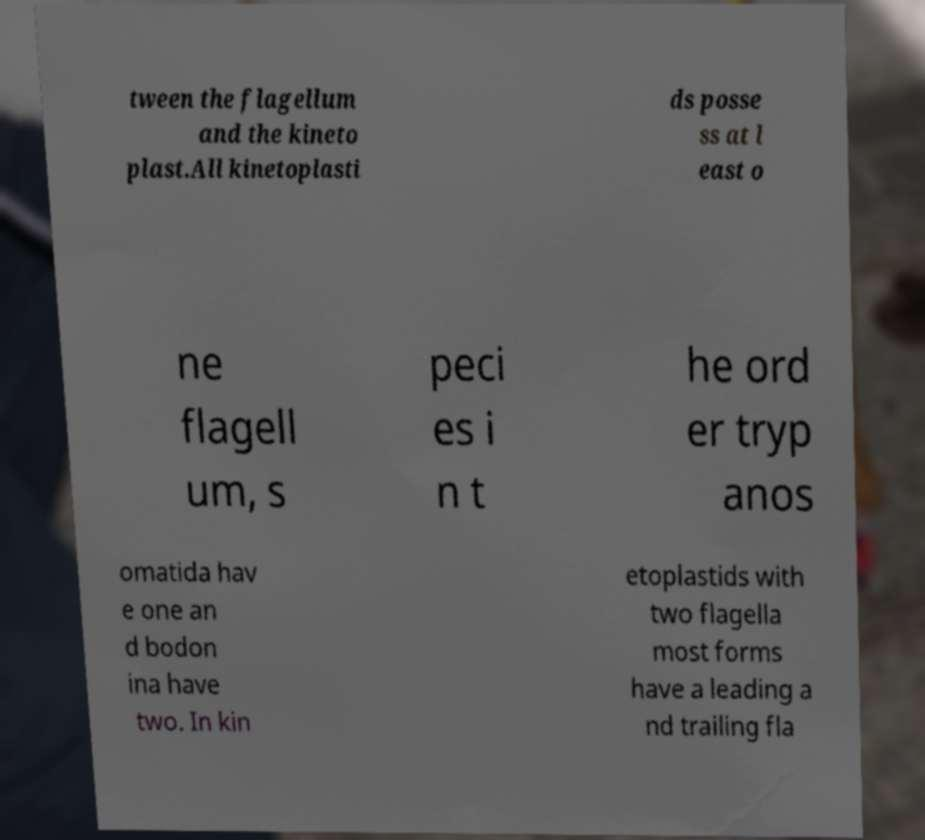Please identify and transcribe the text found in this image. tween the flagellum and the kineto plast.All kinetoplasti ds posse ss at l east o ne flagell um, s peci es i n t he ord er tryp anos omatida hav e one an d bodon ina have two. In kin etoplastids with two flagella most forms have a leading a nd trailing fla 